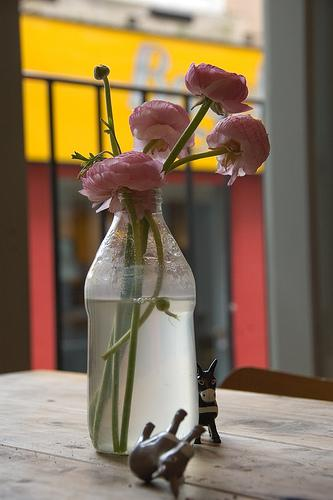What type of doors are present in the image, and what colors are the walls on which they are situated? The image shows a glass door with yellow and red walls in the background. List down the colors of flowers found in this image. In this image, there are pink flowers. What kind of railing is mentioned in the image, and where is it situated? There is a metal railing in the image, and it is located on a balcony. How many flowers are there in the vase, according to the caption information? There are five flowers in the vase. Describe the type of table in the image, and what is its surface made of? The table in the image is wooden with a smooth surface. Mention one prominent color of the wall in the background. One prominent color of the wall in the background is yellow. What materials are the two described toys made of in the image? The two toys in this image are made of plastic and are small, black donkey figurines. How many donkey figurines are there in the image and what are they doing? There are two donkey figurines in the image, both standing on a wooden table. Which object in the image has the sunlight shining on it? The sunlight is shining on the glass vase in this image. What object holds the flowers in the image and what is it made of? A transparent, glass vase holds the flowers in the image. 